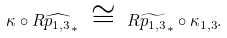<formula> <loc_0><loc_0><loc_500><loc_500>\kappa \circ R \widehat { p _ { 1 , 3 } } _ { * } \ \cong \ R \widetilde { p _ { 1 , 3 } } _ { * } \circ \kappa _ { 1 , 3 } .</formula> 